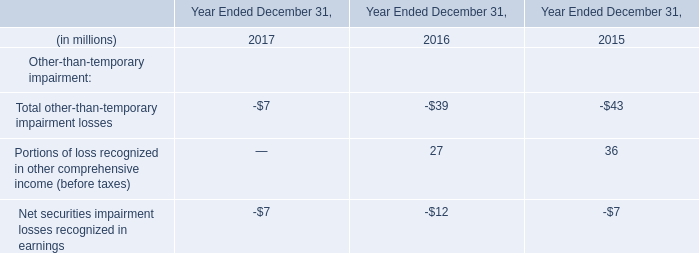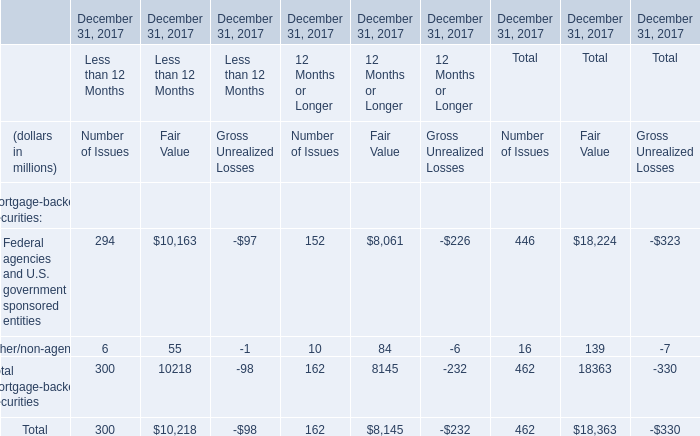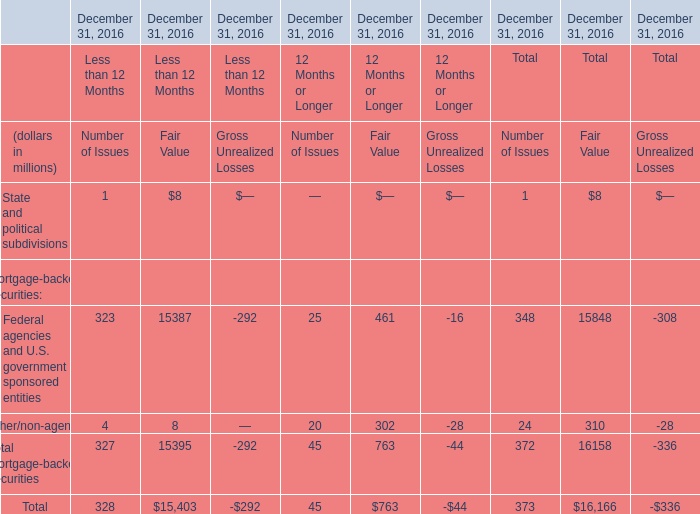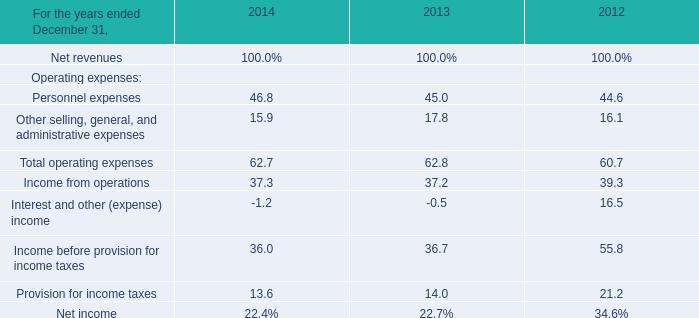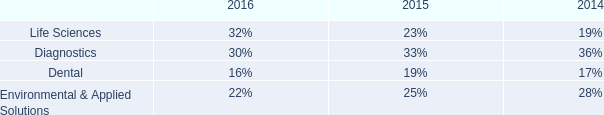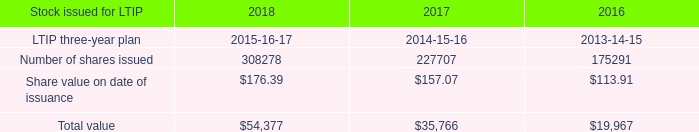What is the sum of Personnel expenses in 2014 and Number of shares issued in 2018 ? 
Computations: (46.8 + 308278)
Answer: 308324.8. 